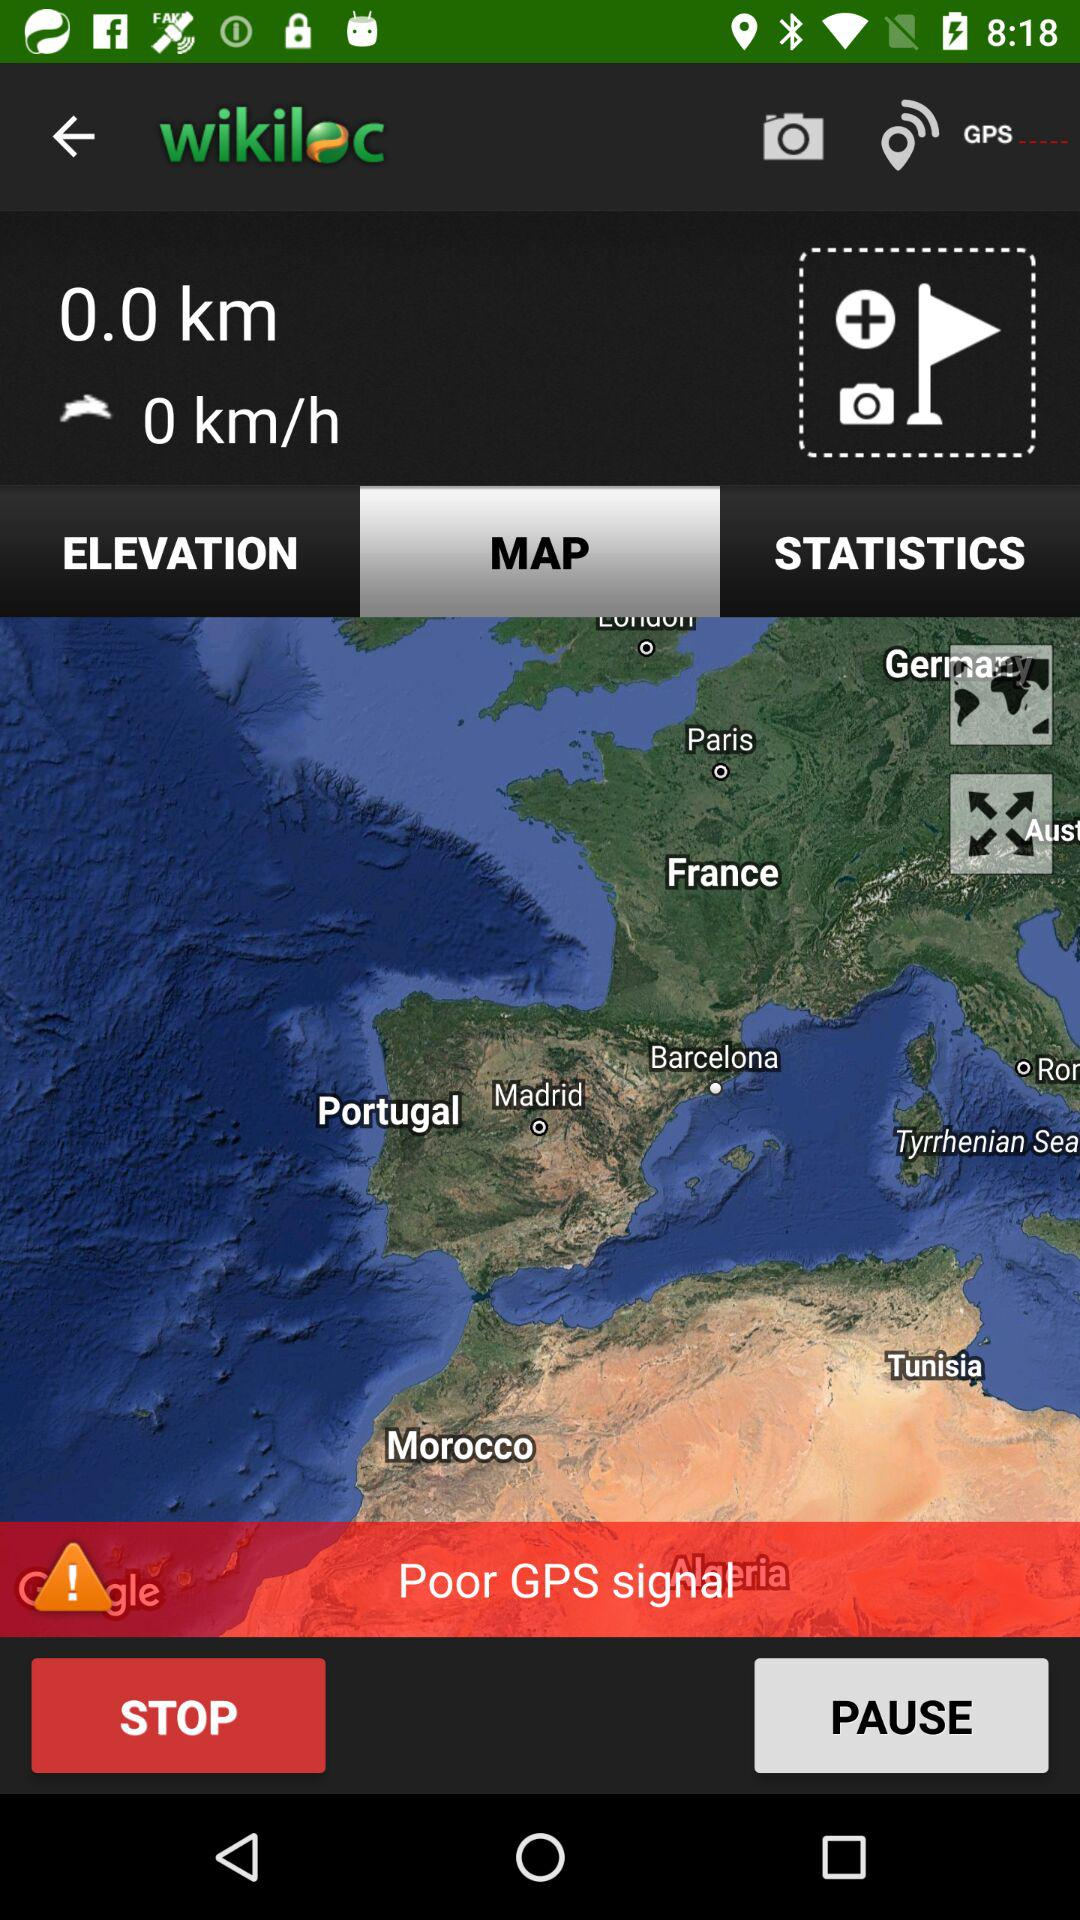Which option is selected? The selected option is "MAP". 